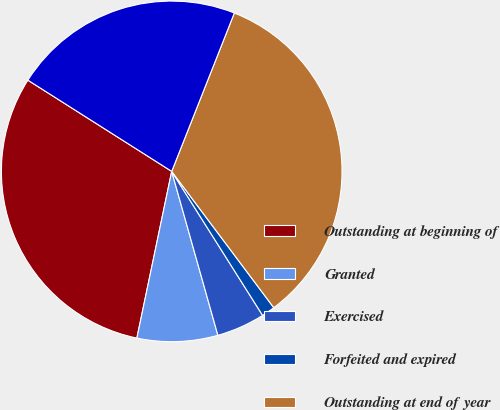Convert chart to OTSL. <chart><loc_0><loc_0><loc_500><loc_500><pie_chart><fcel>Outstanding at beginning of<fcel>Granted<fcel>Exercised<fcel>Forfeited and expired<fcel>Outstanding at end of year<fcel>Options exercisable at year-<nl><fcel>30.72%<fcel>7.65%<fcel>4.59%<fcel>1.27%<fcel>33.78%<fcel>22.0%<nl></chart> 